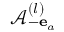Convert formula to latex. <formula><loc_0><loc_0><loc_500><loc_500>\mathcal { A } _ { - { e } _ { a } } ^ { ( l ) }</formula> 